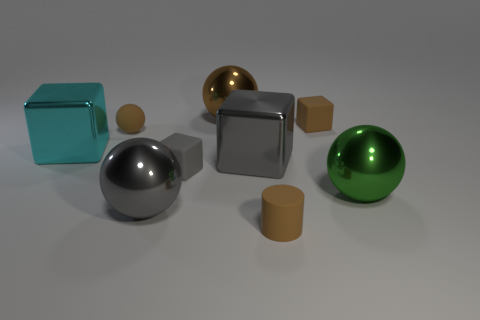Subtract all big green metal balls. How many balls are left? 3 Add 1 tiny gray matte blocks. How many objects exist? 10 Subtract all brown balls. How many balls are left? 2 Subtract 1 green spheres. How many objects are left? 8 Subtract all cylinders. How many objects are left? 8 Subtract 2 blocks. How many blocks are left? 2 Subtract all gray cubes. Subtract all brown cylinders. How many cubes are left? 2 Subtract all purple balls. How many gray cubes are left? 2 Subtract all large cyan metal blocks. Subtract all large metal things. How many objects are left? 3 Add 6 large metal cubes. How many large metal cubes are left? 8 